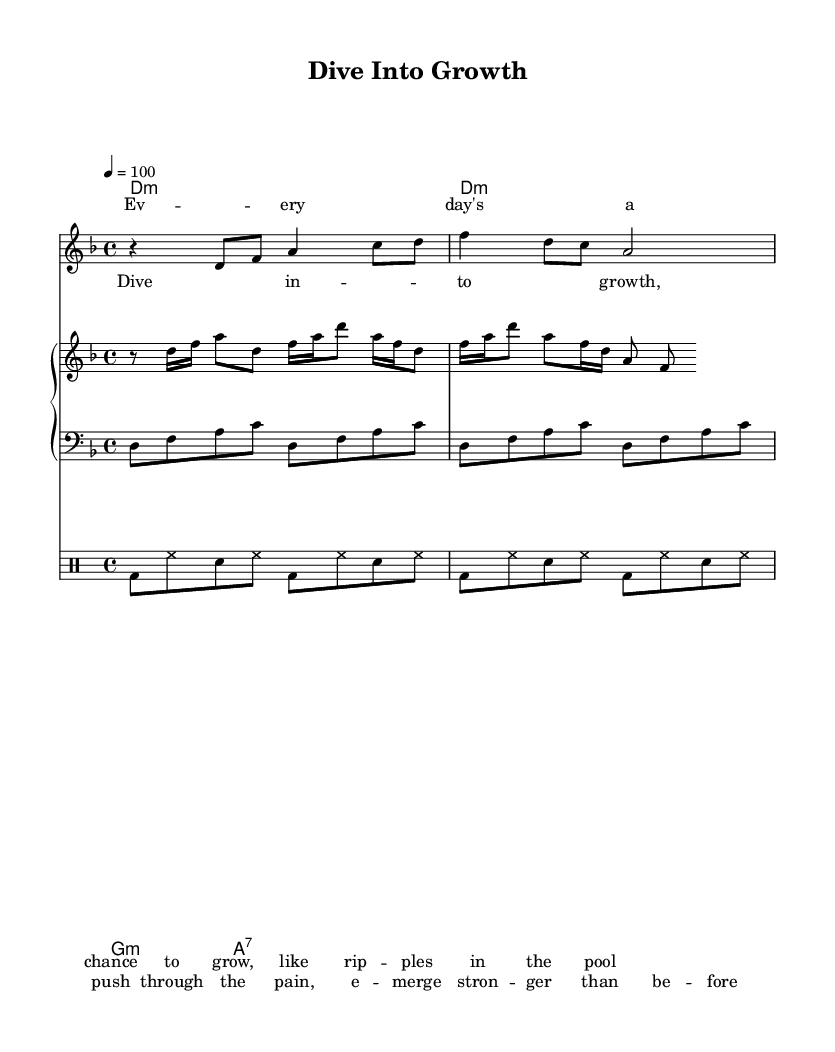What is the time signature of this music? The time signature is indicated at the beginning of the score, where it shows "4/4," meaning there are four beats in each measure, and the quarter note gets one beat.
Answer: 4/4 What is the key signature of this music? The key signature corresponds to D minor, as indicated by the presence of one flat (B♭) in the key signature section at the beginning of the score.
Answer: D minor What is the tempo marking of this piece? The tempo marking is represented at the top of the score, showing "4 = 100," which means there are 100 beats per minute.
Answer: 100 How many measures are in the vocal melody section? The vocal melody consists of two lines, each containing four measures, so there are a total of eight measures in the vocal melody.
Answer: 8 What chord is played during the chorus section? The chords for the chorus can be found in the chord section aligned with the vocal melody, which lists "D minor, G minor, A7" played across the measures of the chorus.
Answer: D minor, G minor, A7 How does the drum pattern contribute to the overall funk feel of the piece? The drum pattern features a strong backbeat created by a combination of bass drum and snare, emphasizing the second and fourth beats, which is characteristic of funk rhythms.
Answer: Strong backbeat What lyrical theme does the song convey? The lyrics talk about personal growth and self-improvement, suggesting themes of resilience and transformation, specifically mentioning "dive into growth" and pushing through pain.
Answer: Personal growth and self-improvement 